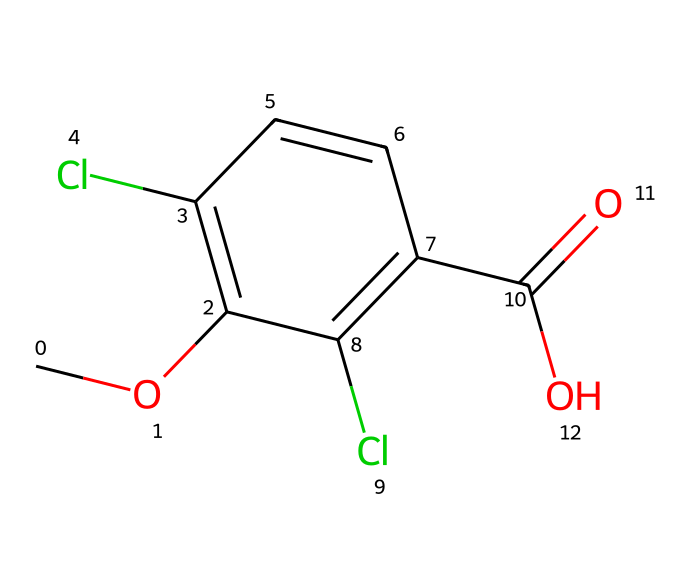What is the total number of carbon atoms in this molecule? The SMILES indicates that each 'C' represents a carbon atom. Counting the carbon atoms in the structure gives a total of 8 carbon atoms.
Answer: 8 How many chlorine atoms are present in the structure? The SMILES notation shows two occurrences of 'Cl', indicating that there are two chlorine atoms in the molecule.
Answer: 2 What functional group is present at the end of this molecule? The presence of 'C(=O)O' indicates a carboxylic acid functional group, as it involves a carbonyl (C=O) and a hydroxyl (-OH) functional group at the end of the structure.
Answer: carboxylic acid Which part of the molecule contributes to its herbicidal activity? The molecular structure's configuration resembles natural auxins that regulate plant growth, particularly the carboxylic acid part, which is essential for its herbicide activity by mimicking plant hormones.
Answer: carboxylic acid What is the likely consequence of dicamba's drift to non-target plants? Due to its structure resembling natural plant hormones (auxins), dicamba can cause uncontrolled growth responses in non-target plants if drift occurs, potentially damaging those plants.
Answer: uncontrolled growth How many double bonds are present in this molecule? The structure includes a double bond in the carboxylic acid functional group (C=O) and an aromatic benzene ring with one additional double bond between carbons. This totals two double bonds in the molecule.
Answer: 2 